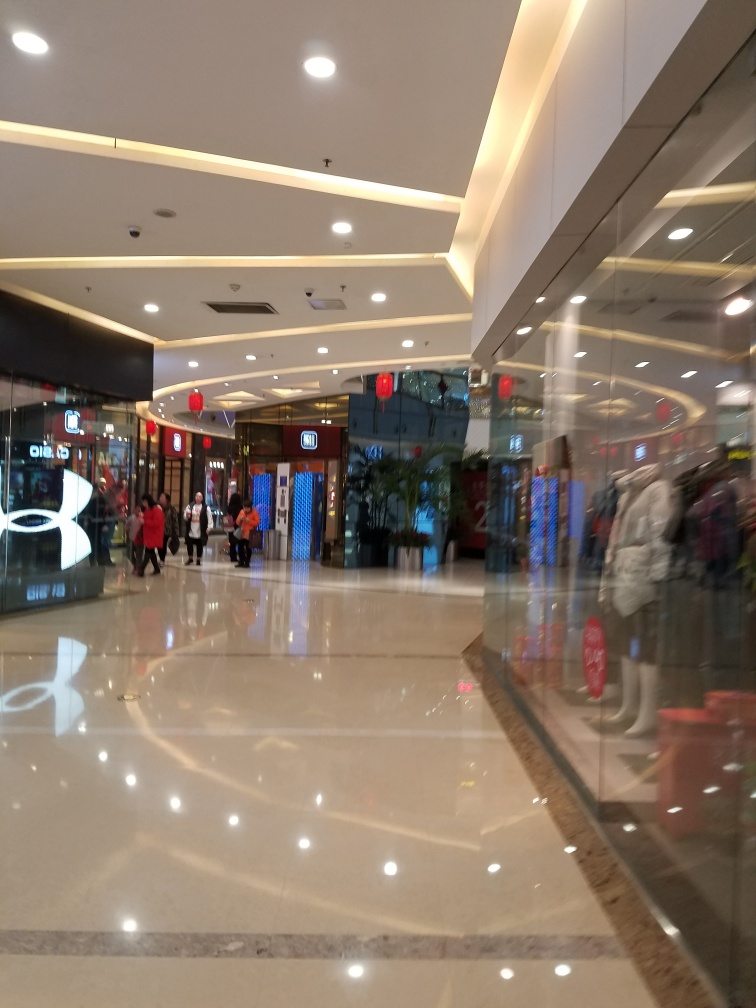What do you think could be improved in this commercial space for better customer experience? Improving the customer experience could involve a few strategies. Enhanced lighting to ensure even illumination without glare would make the space more welcoming. Adding more seating areas could provide comfort to shoppers wishing to rest. Interactive directories could help visitors navigate the mall with ease. Lastly, ambient music and infusing natural elements like plants could create a more relaxed shopping environment. 